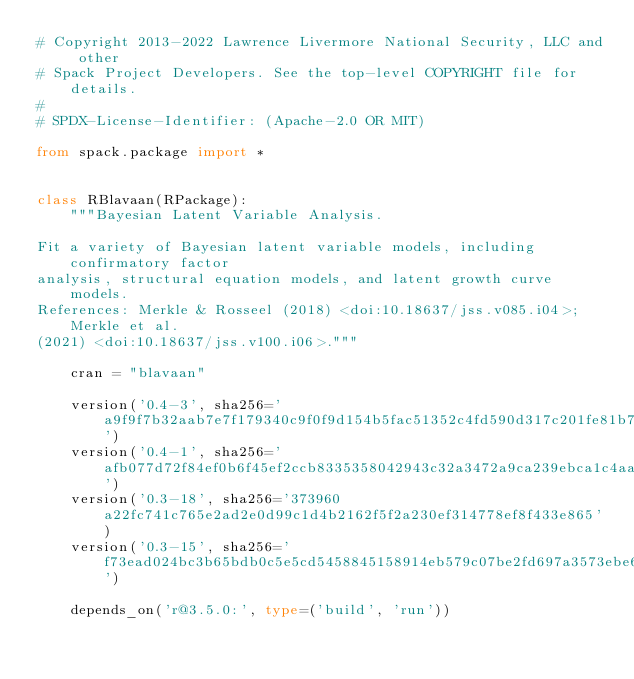Convert code to text. <code><loc_0><loc_0><loc_500><loc_500><_Python_># Copyright 2013-2022 Lawrence Livermore National Security, LLC and other
# Spack Project Developers. See the top-level COPYRIGHT file for details.
#
# SPDX-License-Identifier: (Apache-2.0 OR MIT)

from spack.package import *


class RBlavaan(RPackage):
    """Bayesian Latent Variable Analysis.

Fit a variety of Bayesian latent variable models, including confirmatory factor
analysis, structural equation models, and latent growth curve models.
References: Merkle & Rosseel (2018) <doi:10.18637/jss.v085.i04>; Merkle et al.
(2021) <doi:10.18637/jss.v100.i06>."""

    cran = "blavaan"

    version('0.4-3', sha256='a9f9f7b32aab7e7f179340c9f0f9d154b5fac51352c4fd590d317c201fe81b74')
    version('0.4-1', sha256='afb077d72f84ef0b6f45ef2ccb8335358042943c32a3472a9ca239ebca1c4aa4')
    version('0.3-18', sha256='373960a22fc741c765e2ad2e0d99c1d4b2162f5f2a230ef314778ef8f433e865')
    version('0.3-15', sha256='f73ead024bc3b65bdb0c5e5cd5458845158914eb579c07be2fd697a3573ebe6f')

    depends_on('r@3.5.0:', type=('build', 'run'))</code> 